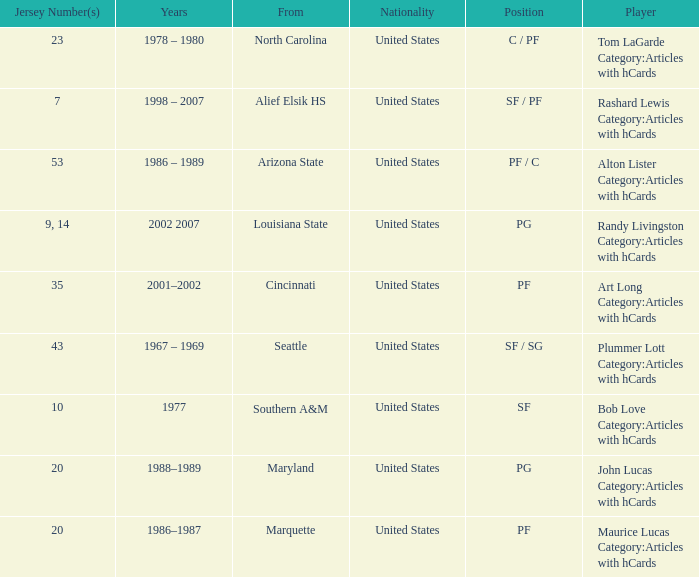The player from Alief Elsik Hs has what as a nationality? United States. 